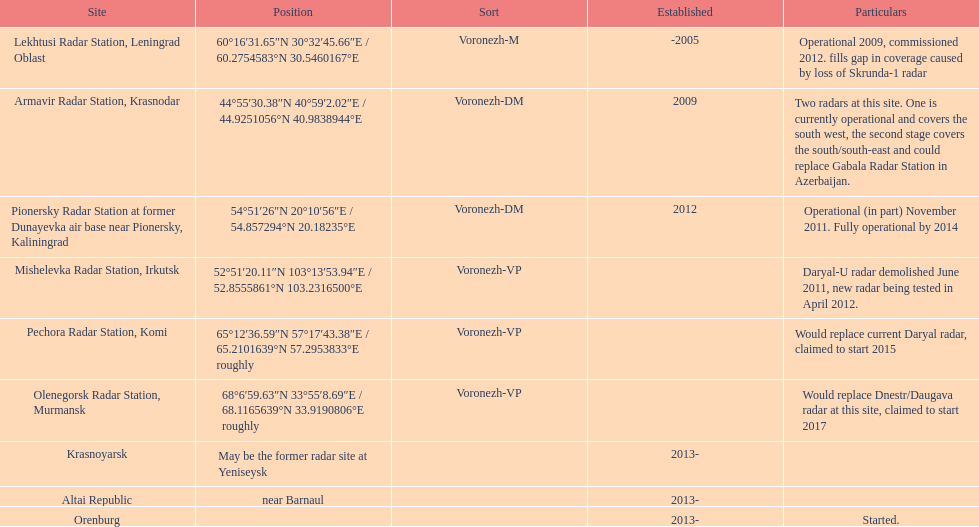What is the total number of locations? 9. 